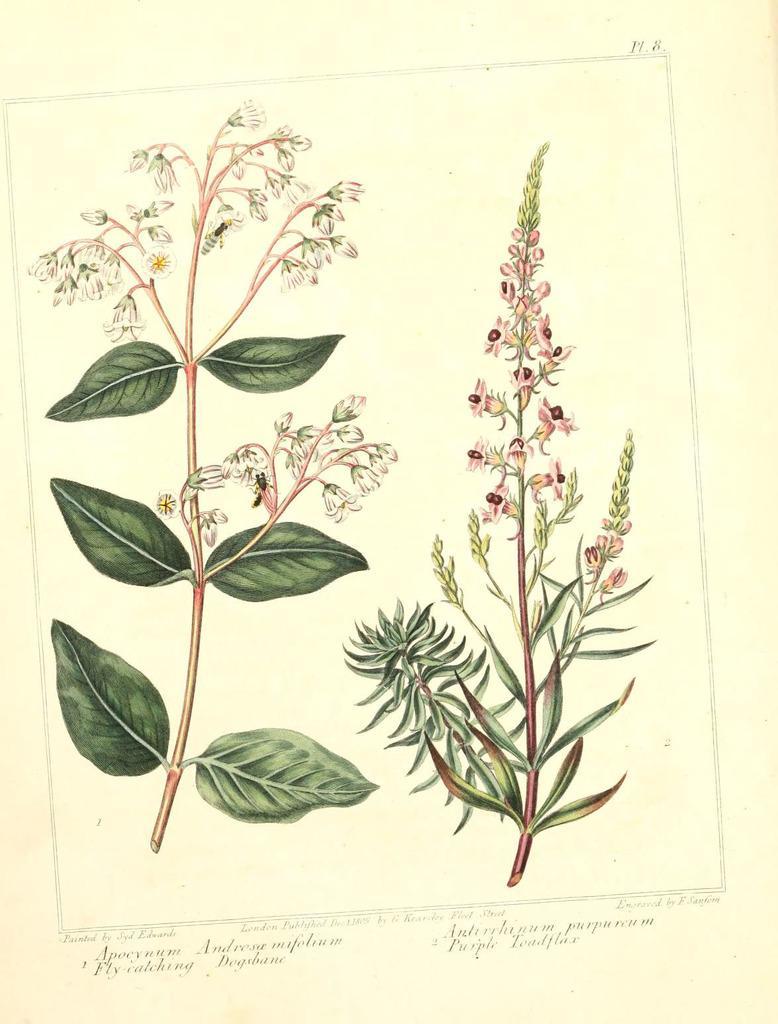In one or two sentences, can you explain what this image depicts? In this picture I can see the paper in front, on which there are depiction pictures of plants. On the bottom of this picture I see something is written and on the top right corner of this image I see 2 alphabets written. 